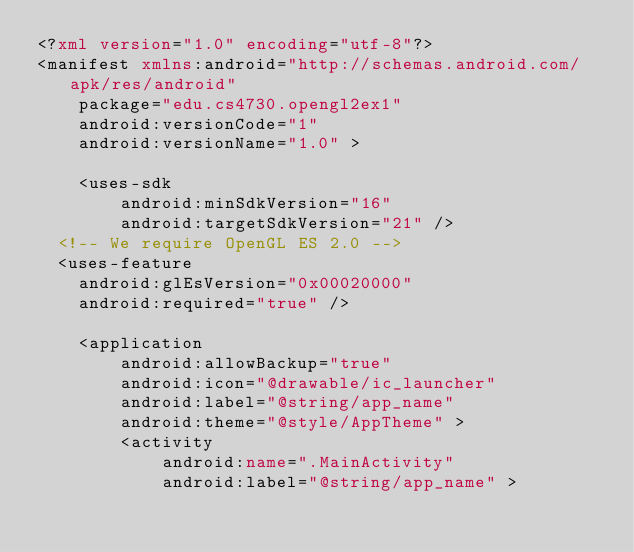<code> <loc_0><loc_0><loc_500><loc_500><_XML_><?xml version="1.0" encoding="utf-8"?>
<manifest xmlns:android="http://schemas.android.com/apk/res/android"
    package="edu.cs4730.opengl2ex1"
    android:versionCode="1"
    android:versionName="1.0" >

    <uses-sdk
        android:minSdkVersion="16"
        android:targetSdkVersion="21" />
	<!-- We require OpenGL ES 2.0 -->
	<uses-feature
		android:glEsVersion="0x00020000"
		android:required="true" />
    
    <application
        android:allowBackup="true"
        android:icon="@drawable/ic_launcher"
        android:label="@string/app_name"
        android:theme="@style/AppTheme" >
        <activity
            android:name=".MainActivity"
            android:label="@string/app_name" ></code> 